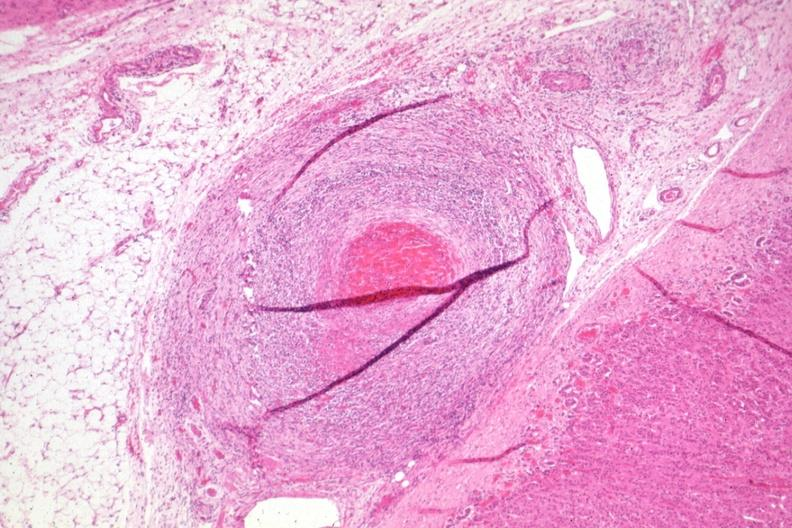does lower chest and abdomen anterior show healing lesion in medium size artery just outside adrenal capsule section has folds?
Answer the question using a single word or phrase. No 